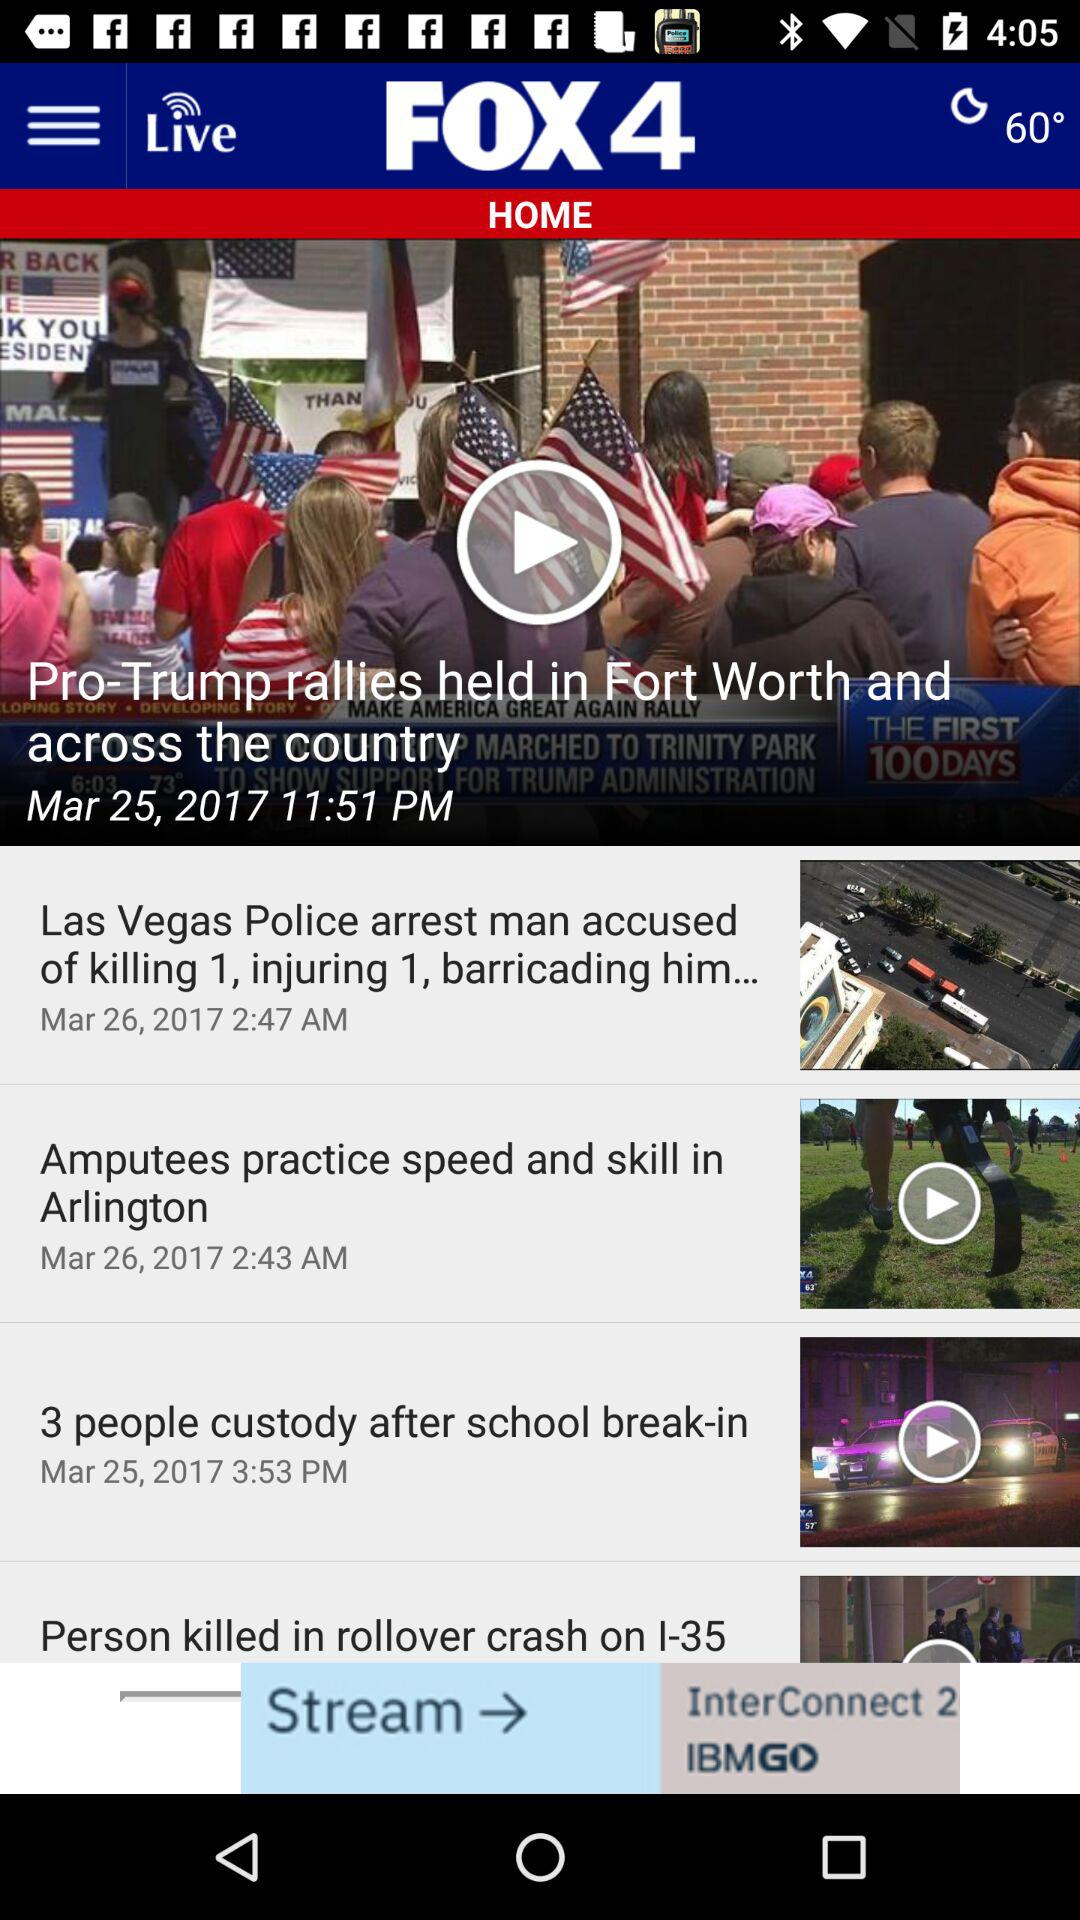What is the news title? The news titles are "Pro-Trump rallies held in Fort Worth and AMERICA GREAT AGAIN RALLY across the country", "Las Vegas Police arrest man accused of killing 1, injuring 1, barricading him...", "Amputees practice speed and skill in Arlington" and "3 people custody after school break-in". 